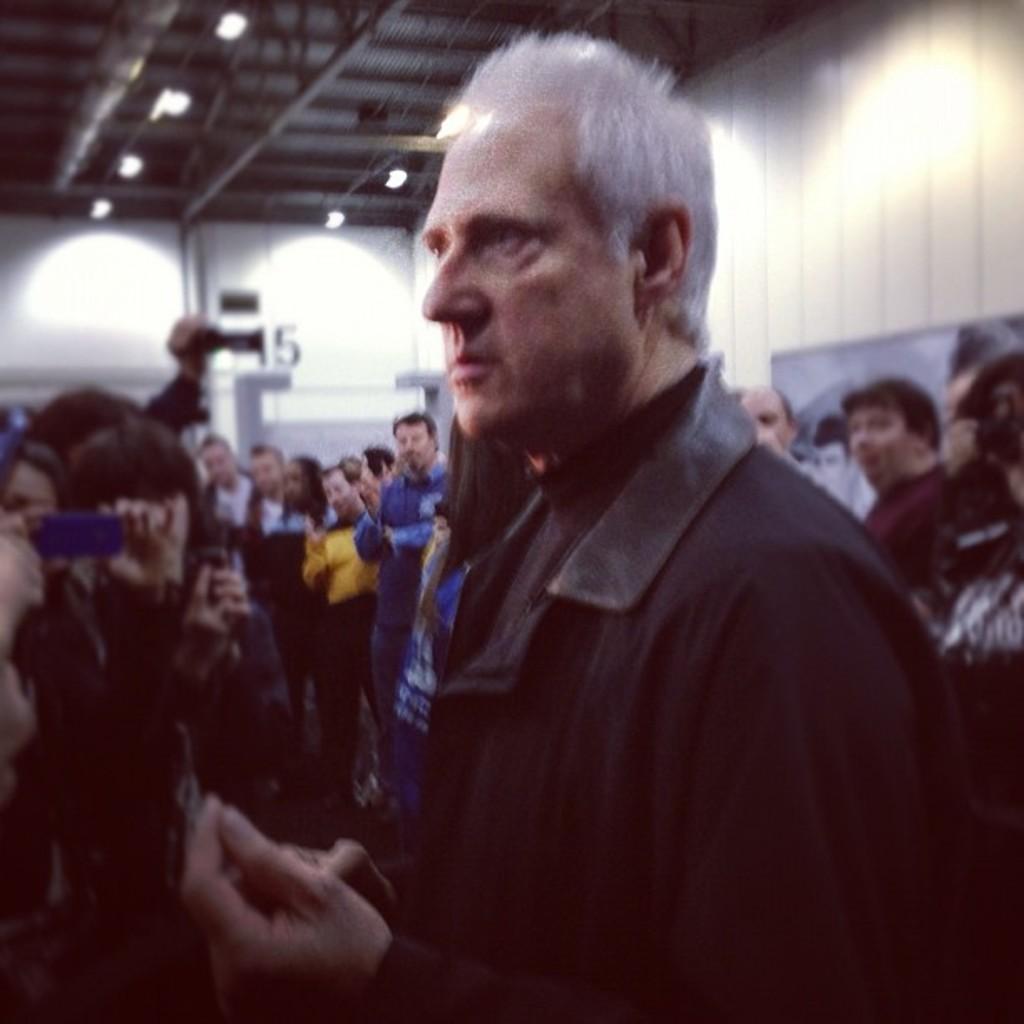Describe this image in one or two sentences. This picture is taken inside the room. In this image, in the middle, we can see a man wearing a black color shirt. In the background, we can see a group of people and few people are holding camera in their hand. In the background, we can also see a white color wall. At the top, we can see a roof with few lights. 